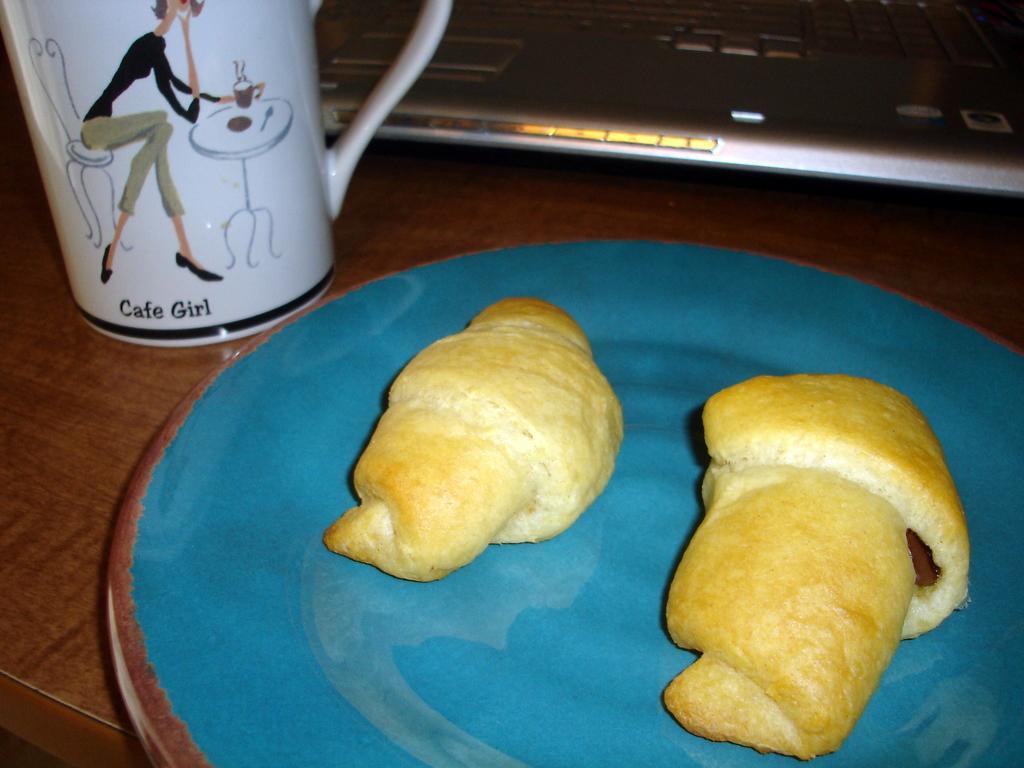In one or two sentences, can you explain what this image depicts? This image consists of food which is on the plate in the center. On the top there is a laptop and on the left side there is a cup which is white in colour. 